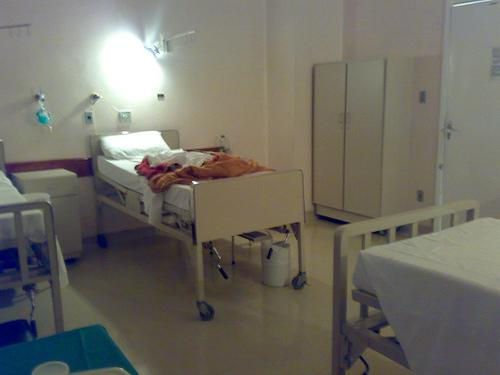List three objects in the image and their colors. A beige closed cabinet, an orange blanket on the hospital bed, and a white closed door. Identify the type of room captured in the image and two objects that support your observation. Hospital room; objects that support this are the hospital beds and IV with blue liquid in it. Can you identify the color and state of the hospital bed sheets in the image? The sheets on the hospital beds are white and empty. Examine the image and provide a brief description of the lighting condition and an object associated with it. The light is on, and it's white, creating a circle of light on the wall above one of the hospital beds. Identify one piece of furniture next to the beds in the image and its color. There's a nightstand in the hospital room next to the beds, which is beige in color. What type of furniture mainly dominates the image? Specify its color and condition. Hospital beds dominate the image, which are white and empty. What is the primary setting of this image? A hospital room with multiple hospital beds and objects such as cabinets, doors, and a circle of light on the wall. 